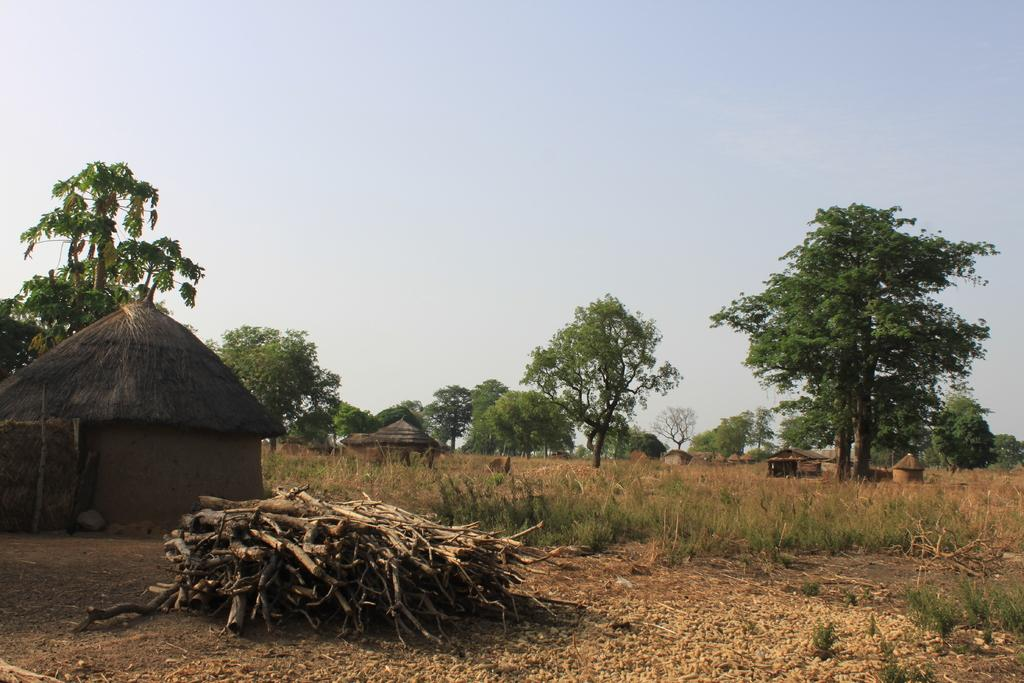What type of structures are visible in the image? There are huts in the image. What type of vegetation is present in the image? There are trees, plants, and twigs visible in the image. What is visible at the top of the image? The sky is visible at the top of the image. Can you see a monkey swinging from a cord on the sidewalk in the image? There is no monkey or sidewalk present in the image; it features huts, trees, plants, twigs, and the sky. 